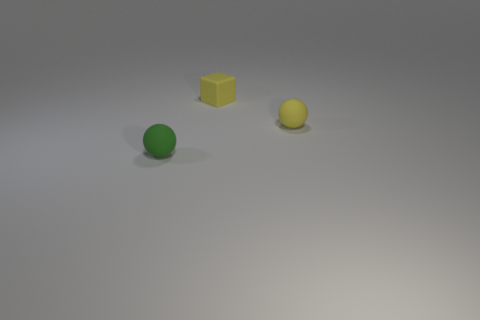Add 3 small blue shiny balls. How many objects exist? 6 Subtract all cubes. How many objects are left? 2 Subtract all matte balls. Subtract all large matte cubes. How many objects are left? 1 Add 3 small yellow balls. How many small yellow balls are left? 4 Add 2 tiny yellow things. How many tiny yellow things exist? 4 Subtract 0 blue spheres. How many objects are left? 3 